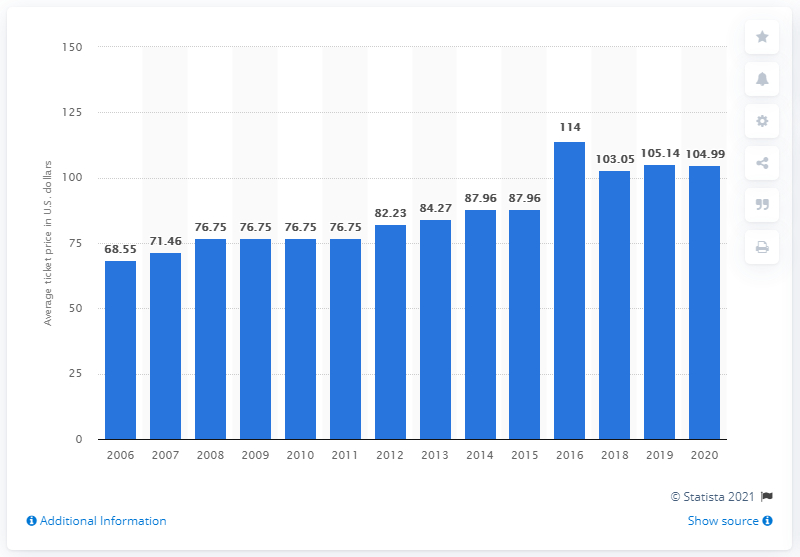Outline some significant characteristics in this image. The average ticket price for Denver Broncos games in 2020 was $104.99. 